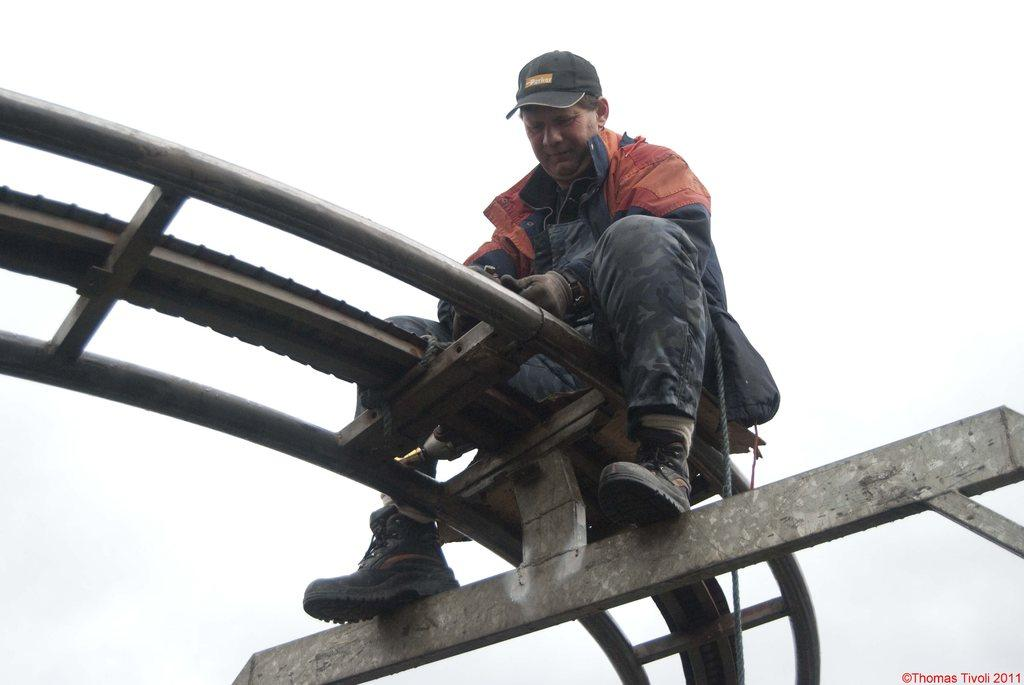Who is the main subject in the image? There is a man in the image. What is the man doing in the image? The man is sitting on top of a stand. Where is the stand located in the image? The stand is in the center of the image. What is the weather like in the image? The sky is cloudy in the image. What type of celery is the man holding in the image? There is no celery present in the image. What role does the actor play in the image? There is no actor or specific role mentioned in the image. 